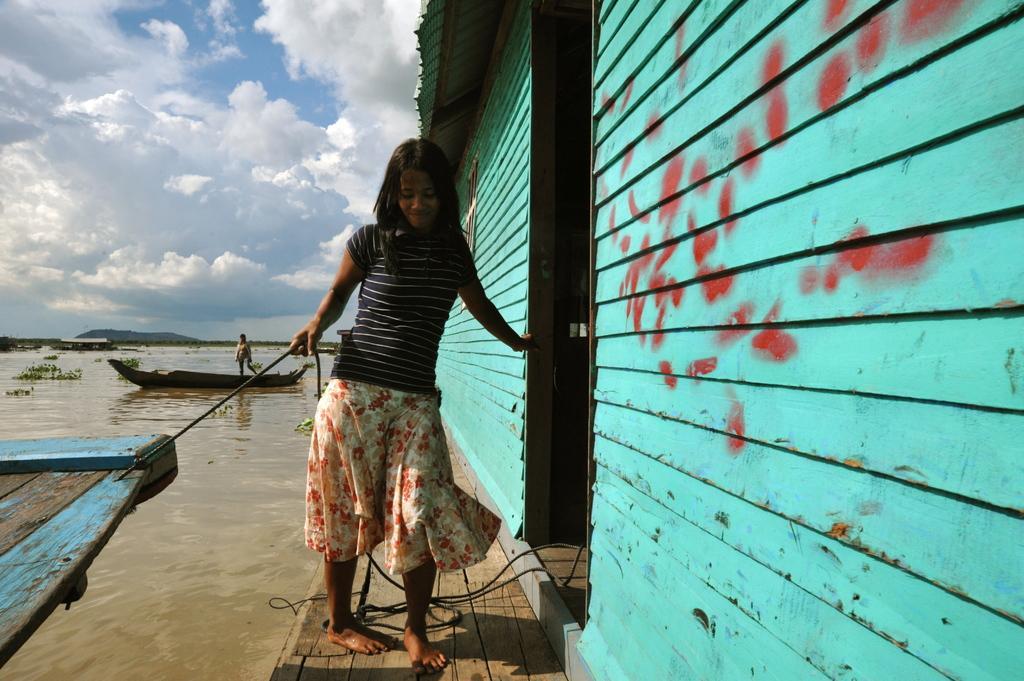In one or two sentences, can you explain what this image depicts? In this image I can see a women is standing and I can see she is holding a black colour rope. Here I can see a building and in the background I can see water, clouds and the sky. I can also see a boat and a person in background. 